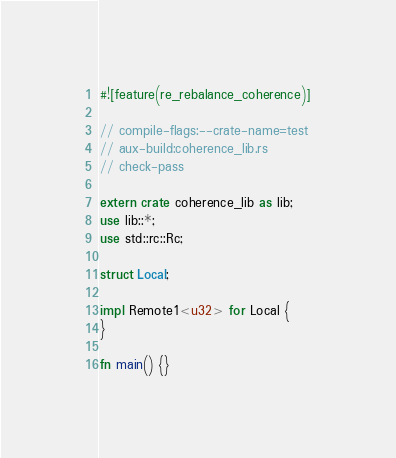Convert code to text. <code><loc_0><loc_0><loc_500><loc_500><_Rust_>#![feature(re_rebalance_coherence)]

// compile-flags:--crate-name=test
// aux-build:coherence_lib.rs
// check-pass

extern crate coherence_lib as lib;
use lib::*;
use std::rc::Rc;

struct Local;

impl Remote1<u32> for Local {
}

fn main() {}
</code> 